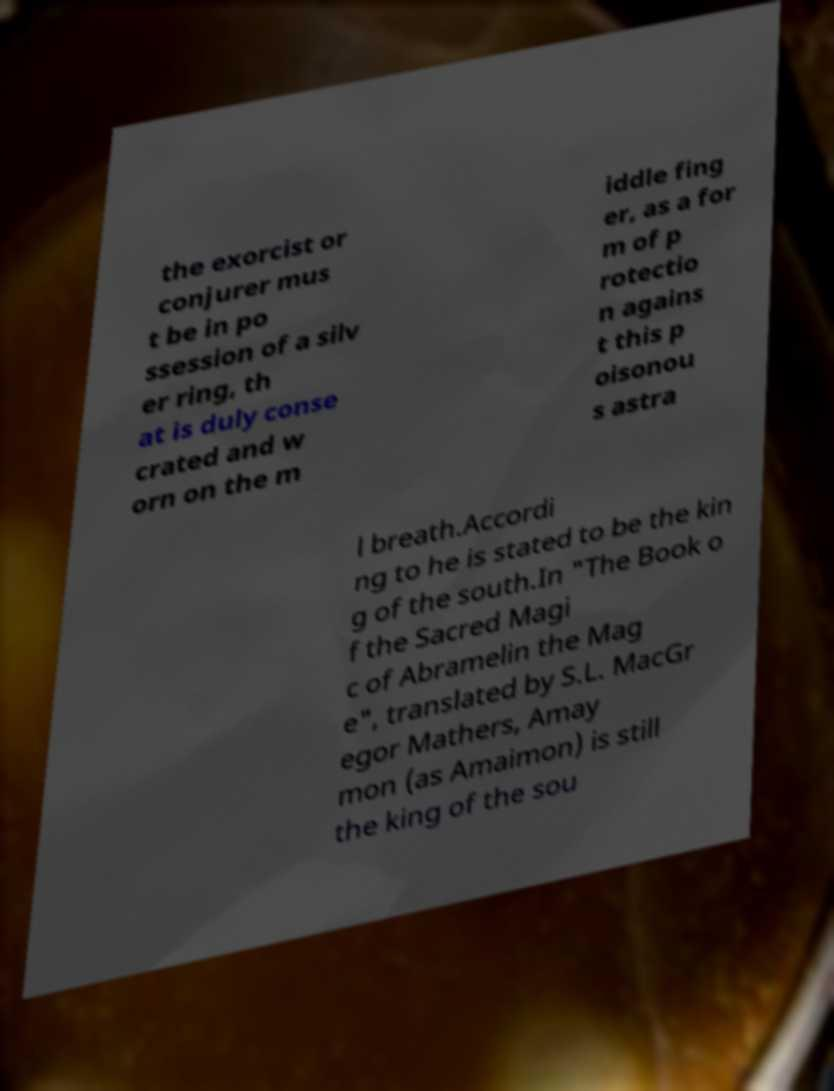Please identify and transcribe the text found in this image. the exorcist or conjurer mus t be in po ssession of a silv er ring, th at is duly conse crated and w orn on the m iddle fing er, as a for m of p rotectio n agains t this p oisonou s astra l breath.Accordi ng to he is stated to be the kin g of the south.In "The Book o f the Sacred Magi c of Abramelin the Mag e", translated by S.L. MacGr egor Mathers, Amay mon (as Amaimon) is still the king of the sou 